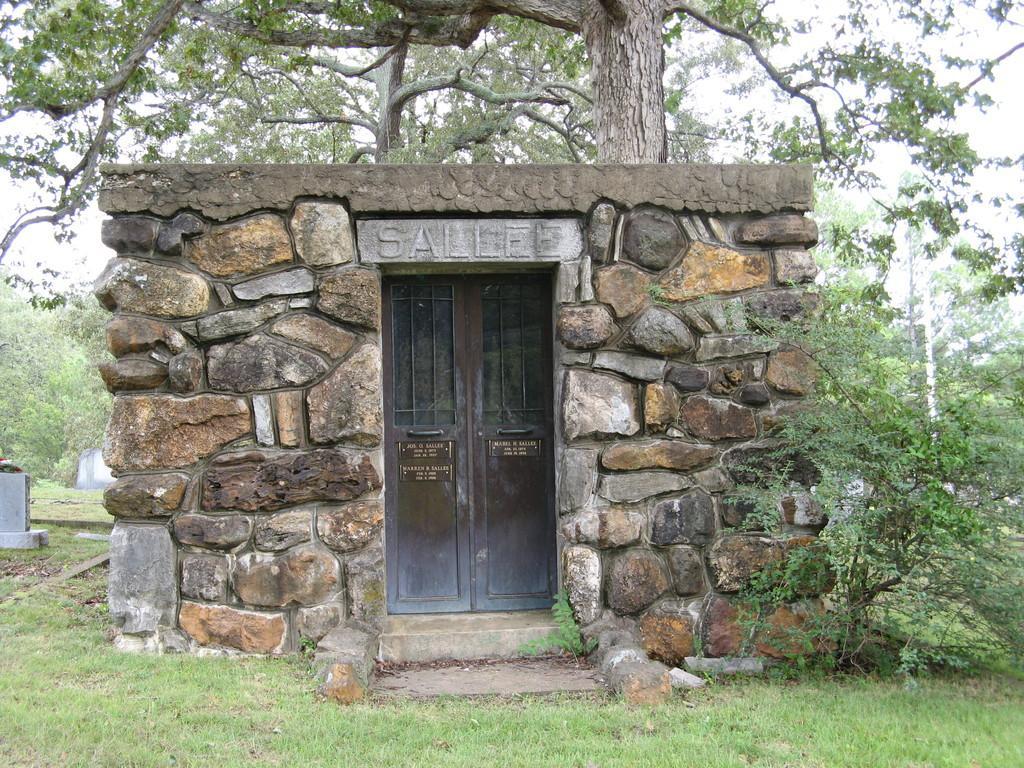In one or two sentences, can you explain what this image depicts? In this image we can see a house with a door. We can also see some grass, plants, the bark of the tree, a group of trees and the sky which looks cloudy. 